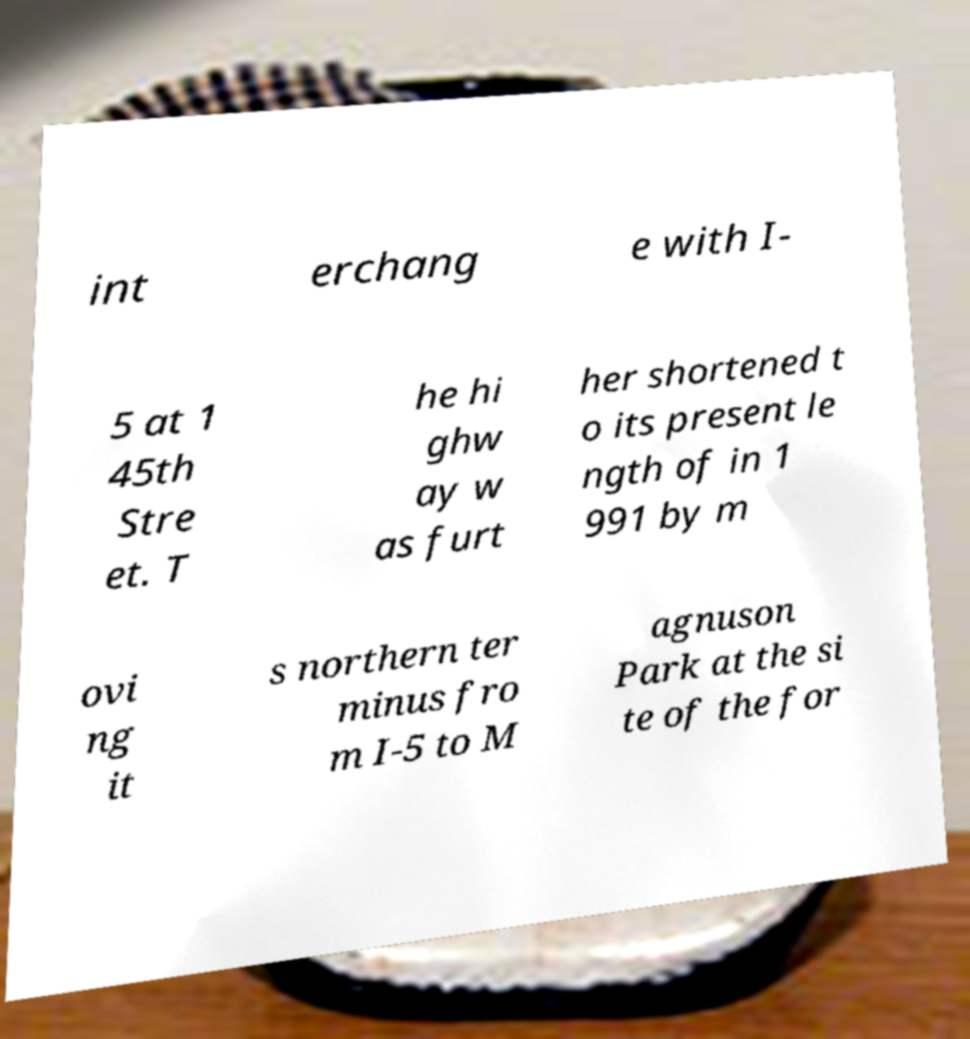I need the written content from this picture converted into text. Can you do that? int erchang e with I- 5 at 1 45th Stre et. T he hi ghw ay w as furt her shortened t o its present le ngth of in 1 991 by m ovi ng it s northern ter minus fro m I-5 to M agnuson Park at the si te of the for 